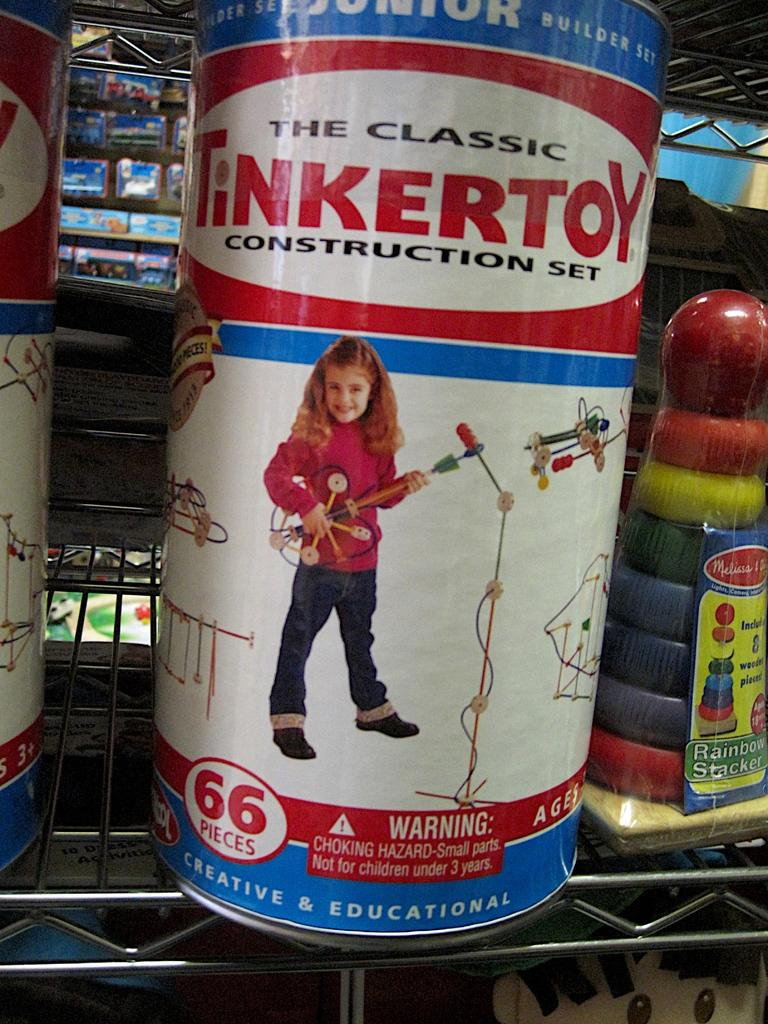What type of containers are visible in the image? There are tins in the image. What is placed on a rack in the image? There is an object placed on a rack in the image. What can be seen in the background of the image? There are boxes in the background of the image. What type of chair is used by the manager in the image? There is no manager or chair present in the image. How does the sleet affect the visibility of the objects in the image? There is no sleet present in the image, so it does not affect the visibility of the objects. 